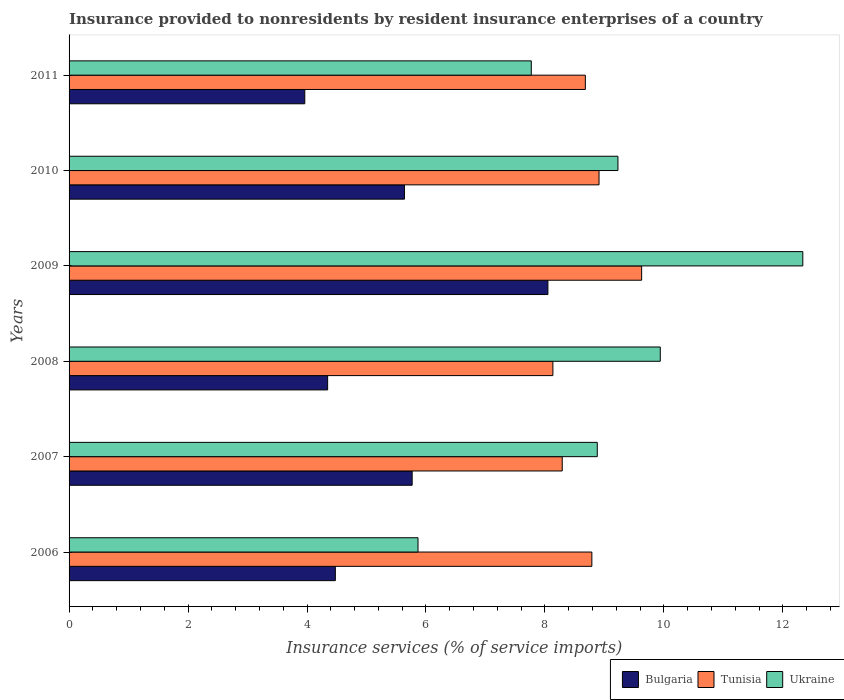How many different coloured bars are there?
Keep it short and to the point. 3. How many groups of bars are there?
Offer a very short reply. 6. Are the number of bars on each tick of the Y-axis equal?
Keep it short and to the point. Yes. What is the insurance provided to nonresidents in Tunisia in 2006?
Provide a succinct answer. 8.79. Across all years, what is the maximum insurance provided to nonresidents in Tunisia?
Ensure brevity in your answer.  9.63. Across all years, what is the minimum insurance provided to nonresidents in Ukraine?
Offer a terse response. 5.87. In which year was the insurance provided to nonresidents in Bulgaria minimum?
Ensure brevity in your answer.  2011. What is the total insurance provided to nonresidents in Bulgaria in the graph?
Keep it short and to the point. 32.24. What is the difference between the insurance provided to nonresidents in Bulgaria in 2006 and that in 2008?
Offer a terse response. 0.13. What is the difference between the insurance provided to nonresidents in Bulgaria in 2010 and the insurance provided to nonresidents in Ukraine in 2008?
Ensure brevity in your answer.  -4.3. What is the average insurance provided to nonresidents in Bulgaria per year?
Give a very brief answer. 5.37. In the year 2010, what is the difference between the insurance provided to nonresidents in Ukraine and insurance provided to nonresidents in Bulgaria?
Keep it short and to the point. 3.59. In how many years, is the insurance provided to nonresidents in Ukraine greater than 7.6 %?
Offer a very short reply. 5. What is the ratio of the insurance provided to nonresidents in Ukraine in 2007 to that in 2011?
Keep it short and to the point. 1.14. Is the insurance provided to nonresidents in Ukraine in 2007 less than that in 2010?
Your answer should be very brief. Yes. Is the difference between the insurance provided to nonresidents in Ukraine in 2007 and 2010 greater than the difference between the insurance provided to nonresidents in Bulgaria in 2007 and 2010?
Your response must be concise. No. What is the difference between the highest and the second highest insurance provided to nonresidents in Ukraine?
Your answer should be compact. 2.4. What is the difference between the highest and the lowest insurance provided to nonresidents in Tunisia?
Provide a short and direct response. 1.49. In how many years, is the insurance provided to nonresidents in Tunisia greater than the average insurance provided to nonresidents in Tunisia taken over all years?
Your response must be concise. 3. What does the 2nd bar from the top in 2011 represents?
Offer a terse response. Tunisia. Is it the case that in every year, the sum of the insurance provided to nonresidents in Tunisia and insurance provided to nonresidents in Ukraine is greater than the insurance provided to nonresidents in Bulgaria?
Your answer should be compact. Yes. How many bars are there?
Ensure brevity in your answer.  18. What is the difference between two consecutive major ticks on the X-axis?
Provide a succinct answer. 2. Where does the legend appear in the graph?
Make the answer very short. Bottom right. How many legend labels are there?
Give a very brief answer. 3. How are the legend labels stacked?
Your answer should be very brief. Horizontal. What is the title of the graph?
Your response must be concise. Insurance provided to nonresidents by resident insurance enterprises of a country. What is the label or title of the X-axis?
Offer a very short reply. Insurance services (% of service imports). What is the Insurance services (% of service imports) in Bulgaria in 2006?
Your answer should be very brief. 4.48. What is the Insurance services (% of service imports) of Tunisia in 2006?
Give a very brief answer. 8.79. What is the Insurance services (% of service imports) of Ukraine in 2006?
Ensure brevity in your answer.  5.87. What is the Insurance services (% of service imports) of Bulgaria in 2007?
Give a very brief answer. 5.77. What is the Insurance services (% of service imports) in Tunisia in 2007?
Ensure brevity in your answer.  8.29. What is the Insurance services (% of service imports) of Ukraine in 2007?
Your response must be concise. 8.88. What is the Insurance services (% of service imports) in Bulgaria in 2008?
Make the answer very short. 4.35. What is the Insurance services (% of service imports) in Tunisia in 2008?
Your answer should be very brief. 8.13. What is the Insurance services (% of service imports) of Ukraine in 2008?
Your answer should be compact. 9.94. What is the Insurance services (% of service imports) of Bulgaria in 2009?
Offer a very short reply. 8.05. What is the Insurance services (% of service imports) in Tunisia in 2009?
Make the answer very short. 9.63. What is the Insurance services (% of service imports) in Ukraine in 2009?
Keep it short and to the point. 12.34. What is the Insurance services (% of service imports) of Bulgaria in 2010?
Offer a terse response. 5.64. What is the Insurance services (% of service imports) in Tunisia in 2010?
Provide a short and direct response. 8.91. What is the Insurance services (% of service imports) of Ukraine in 2010?
Provide a short and direct response. 9.23. What is the Insurance services (% of service imports) in Bulgaria in 2011?
Ensure brevity in your answer.  3.96. What is the Insurance services (% of service imports) of Tunisia in 2011?
Your answer should be compact. 8.68. What is the Insurance services (% of service imports) in Ukraine in 2011?
Your answer should be very brief. 7.77. Across all years, what is the maximum Insurance services (% of service imports) in Bulgaria?
Ensure brevity in your answer.  8.05. Across all years, what is the maximum Insurance services (% of service imports) in Tunisia?
Your answer should be very brief. 9.63. Across all years, what is the maximum Insurance services (% of service imports) in Ukraine?
Ensure brevity in your answer.  12.34. Across all years, what is the minimum Insurance services (% of service imports) in Bulgaria?
Offer a terse response. 3.96. Across all years, what is the minimum Insurance services (% of service imports) of Tunisia?
Ensure brevity in your answer.  8.13. Across all years, what is the minimum Insurance services (% of service imports) of Ukraine?
Provide a succinct answer. 5.87. What is the total Insurance services (% of service imports) of Bulgaria in the graph?
Ensure brevity in your answer.  32.24. What is the total Insurance services (% of service imports) in Tunisia in the graph?
Your response must be concise. 52.43. What is the total Insurance services (% of service imports) in Ukraine in the graph?
Your answer should be compact. 54.02. What is the difference between the Insurance services (% of service imports) in Bulgaria in 2006 and that in 2007?
Your response must be concise. -1.29. What is the difference between the Insurance services (% of service imports) of Tunisia in 2006 and that in 2007?
Offer a terse response. 0.5. What is the difference between the Insurance services (% of service imports) of Ukraine in 2006 and that in 2007?
Provide a succinct answer. -3.01. What is the difference between the Insurance services (% of service imports) of Bulgaria in 2006 and that in 2008?
Offer a very short reply. 0.13. What is the difference between the Insurance services (% of service imports) of Tunisia in 2006 and that in 2008?
Provide a succinct answer. 0.66. What is the difference between the Insurance services (% of service imports) of Ukraine in 2006 and that in 2008?
Make the answer very short. -4.07. What is the difference between the Insurance services (% of service imports) of Bulgaria in 2006 and that in 2009?
Your answer should be very brief. -3.57. What is the difference between the Insurance services (% of service imports) in Tunisia in 2006 and that in 2009?
Provide a succinct answer. -0.84. What is the difference between the Insurance services (% of service imports) in Ukraine in 2006 and that in 2009?
Ensure brevity in your answer.  -6.47. What is the difference between the Insurance services (% of service imports) in Bulgaria in 2006 and that in 2010?
Ensure brevity in your answer.  -1.16. What is the difference between the Insurance services (% of service imports) in Tunisia in 2006 and that in 2010?
Provide a short and direct response. -0.12. What is the difference between the Insurance services (% of service imports) of Ukraine in 2006 and that in 2010?
Your answer should be very brief. -3.36. What is the difference between the Insurance services (% of service imports) in Bulgaria in 2006 and that in 2011?
Offer a terse response. 0.51. What is the difference between the Insurance services (% of service imports) in Tunisia in 2006 and that in 2011?
Offer a terse response. 0.11. What is the difference between the Insurance services (% of service imports) of Ukraine in 2006 and that in 2011?
Give a very brief answer. -1.9. What is the difference between the Insurance services (% of service imports) in Bulgaria in 2007 and that in 2008?
Your answer should be very brief. 1.42. What is the difference between the Insurance services (% of service imports) of Tunisia in 2007 and that in 2008?
Your answer should be very brief. 0.16. What is the difference between the Insurance services (% of service imports) of Ukraine in 2007 and that in 2008?
Give a very brief answer. -1.06. What is the difference between the Insurance services (% of service imports) in Bulgaria in 2007 and that in 2009?
Provide a short and direct response. -2.28. What is the difference between the Insurance services (% of service imports) of Tunisia in 2007 and that in 2009?
Your answer should be compact. -1.33. What is the difference between the Insurance services (% of service imports) in Ukraine in 2007 and that in 2009?
Provide a short and direct response. -3.46. What is the difference between the Insurance services (% of service imports) in Bulgaria in 2007 and that in 2010?
Your answer should be compact. 0.13. What is the difference between the Insurance services (% of service imports) in Tunisia in 2007 and that in 2010?
Make the answer very short. -0.62. What is the difference between the Insurance services (% of service imports) in Ukraine in 2007 and that in 2010?
Offer a terse response. -0.35. What is the difference between the Insurance services (% of service imports) of Bulgaria in 2007 and that in 2011?
Your response must be concise. 1.81. What is the difference between the Insurance services (% of service imports) in Tunisia in 2007 and that in 2011?
Keep it short and to the point. -0.39. What is the difference between the Insurance services (% of service imports) of Ukraine in 2007 and that in 2011?
Provide a succinct answer. 1.11. What is the difference between the Insurance services (% of service imports) of Bulgaria in 2008 and that in 2009?
Your answer should be very brief. -3.7. What is the difference between the Insurance services (% of service imports) of Tunisia in 2008 and that in 2009?
Offer a very short reply. -1.49. What is the difference between the Insurance services (% of service imports) of Ukraine in 2008 and that in 2009?
Make the answer very short. -2.4. What is the difference between the Insurance services (% of service imports) of Bulgaria in 2008 and that in 2010?
Provide a succinct answer. -1.29. What is the difference between the Insurance services (% of service imports) in Tunisia in 2008 and that in 2010?
Make the answer very short. -0.78. What is the difference between the Insurance services (% of service imports) in Ukraine in 2008 and that in 2010?
Provide a succinct answer. 0.71. What is the difference between the Insurance services (% of service imports) in Bulgaria in 2008 and that in 2011?
Provide a short and direct response. 0.38. What is the difference between the Insurance services (% of service imports) of Tunisia in 2008 and that in 2011?
Your answer should be compact. -0.55. What is the difference between the Insurance services (% of service imports) of Ukraine in 2008 and that in 2011?
Provide a short and direct response. 2.17. What is the difference between the Insurance services (% of service imports) of Bulgaria in 2009 and that in 2010?
Ensure brevity in your answer.  2.41. What is the difference between the Insurance services (% of service imports) in Tunisia in 2009 and that in 2010?
Your answer should be very brief. 0.72. What is the difference between the Insurance services (% of service imports) in Ukraine in 2009 and that in 2010?
Give a very brief answer. 3.11. What is the difference between the Insurance services (% of service imports) of Bulgaria in 2009 and that in 2011?
Offer a terse response. 4.09. What is the difference between the Insurance services (% of service imports) of Tunisia in 2009 and that in 2011?
Offer a terse response. 0.95. What is the difference between the Insurance services (% of service imports) of Ukraine in 2009 and that in 2011?
Provide a succinct answer. 4.56. What is the difference between the Insurance services (% of service imports) in Bulgaria in 2010 and that in 2011?
Your answer should be compact. 1.68. What is the difference between the Insurance services (% of service imports) of Tunisia in 2010 and that in 2011?
Make the answer very short. 0.23. What is the difference between the Insurance services (% of service imports) of Ukraine in 2010 and that in 2011?
Provide a succinct answer. 1.46. What is the difference between the Insurance services (% of service imports) of Bulgaria in 2006 and the Insurance services (% of service imports) of Tunisia in 2007?
Ensure brevity in your answer.  -3.81. What is the difference between the Insurance services (% of service imports) of Bulgaria in 2006 and the Insurance services (% of service imports) of Ukraine in 2007?
Your response must be concise. -4.4. What is the difference between the Insurance services (% of service imports) of Tunisia in 2006 and the Insurance services (% of service imports) of Ukraine in 2007?
Make the answer very short. -0.09. What is the difference between the Insurance services (% of service imports) in Bulgaria in 2006 and the Insurance services (% of service imports) in Tunisia in 2008?
Ensure brevity in your answer.  -3.66. What is the difference between the Insurance services (% of service imports) in Bulgaria in 2006 and the Insurance services (% of service imports) in Ukraine in 2008?
Keep it short and to the point. -5.46. What is the difference between the Insurance services (% of service imports) in Tunisia in 2006 and the Insurance services (% of service imports) in Ukraine in 2008?
Offer a very short reply. -1.15. What is the difference between the Insurance services (% of service imports) of Bulgaria in 2006 and the Insurance services (% of service imports) of Tunisia in 2009?
Your response must be concise. -5.15. What is the difference between the Insurance services (% of service imports) of Bulgaria in 2006 and the Insurance services (% of service imports) of Ukraine in 2009?
Ensure brevity in your answer.  -7.86. What is the difference between the Insurance services (% of service imports) in Tunisia in 2006 and the Insurance services (% of service imports) in Ukraine in 2009?
Ensure brevity in your answer.  -3.55. What is the difference between the Insurance services (% of service imports) in Bulgaria in 2006 and the Insurance services (% of service imports) in Tunisia in 2010?
Give a very brief answer. -4.43. What is the difference between the Insurance services (% of service imports) of Bulgaria in 2006 and the Insurance services (% of service imports) of Ukraine in 2010?
Ensure brevity in your answer.  -4.75. What is the difference between the Insurance services (% of service imports) of Tunisia in 2006 and the Insurance services (% of service imports) of Ukraine in 2010?
Provide a succinct answer. -0.44. What is the difference between the Insurance services (% of service imports) of Bulgaria in 2006 and the Insurance services (% of service imports) of Tunisia in 2011?
Keep it short and to the point. -4.2. What is the difference between the Insurance services (% of service imports) of Bulgaria in 2006 and the Insurance services (% of service imports) of Ukraine in 2011?
Make the answer very short. -3.29. What is the difference between the Insurance services (% of service imports) of Tunisia in 2006 and the Insurance services (% of service imports) of Ukraine in 2011?
Give a very brief answer. 1.02. What is the difference between the Insurance services (% of service imports) in Bulgaria in 2007 and the Insurance services (% of service imports) in Tunisia in 2008?
Make the answer very short. -2.37. What is the difference between the Insurance services (% of service imports) in Bulgaria in 2007 and the Insurance services (% of service imports) in Ukraine in 2008?
Ensure brevity in your answer.  -4.17. What is the difference between the Insurance services (% of service imports) of Tunisia in 2007 and the Insurance services (% of service imports) of Ukraine in 2008?
Offer a very short reply. -1.65. What is the difference between the Insurance services (% of service imports) of Bulgaria in 2007 and the Insurance services (% of service imports) of Tunisia in 2009?
Give a very brief answer. -3.86. What is the difference between the Insurance services (% of service imports) of Bulgaria in 2007 and the Insurance services (% of service imports) of Ukraine in 2009?
Your answer should be compact. -6.57. What is the difference between the Insurance services (% of service imports) of Tunisia in 2007 and the Insurance services (% of service imports) of Ukraine in 2009?
Offer a terse response. -4.04. What is the difference between the Insurance services (% of service imports) in Bulgaria in 2007 and the Insurance services (% of service imports) in Tunisia in 2010?
Provide a short and direct response. -3.14. What is the difference between the Insurance services (% of service imports) in Bulgaria in 2007 and the Insurance services (% of service imports) in Ukraine in 2010?
Provide a short and direct response. -3.46. What is the difference between the Insurance services (% of service imports) in Tunisia in 2007 and the Insurance services (% of service imports) in Ukraine in 2010?
Keep it short and to the point. -0.94. What is the difference between the Insurance services (% of service imports) of Bulgaria in 2007 and the Insurance services (% of service imports) of Tunisia in 2011?
Offer a terse response. -2.91. What is the difference between the Insurance services (% of service imports) of Bulgaria in 2007 and the Insurance services (% of service imports) of Ukraine in 2011?
Your answer should be compact. -2. What is the difference between the Insurance services (% of service imports) of Tunisia in 2007 and the Insurance services (% of service imports) of Ukraine in 2011?
Ensure brevity in your answer.  0.52. What is the difference between the Insurance services (% of service imports) in Bulgaria in 2008 and the Insurance services (% of service imports) in Tunisia in 2009?
Your answer should be very brief. -5.28. What is the difference between the Insurance services (% of service imports) in Bulgaria in 2008 and the Insurance services (% of service imports) in Ukraine in 2009?
Your answer should be compact. -7.99. What is the difference between the Insurance services (% of service imports) in Tunisia in 2008 and the Insurance services (% of service imports) in Ukraine in 2009?
Offer a terse response. -4.2. What is the difference between the Insurance services (% of service imports) in Bulgaria in 2008 and the Insurance services (% of service imports) in Tunisia in 2010?
Ensure brevity in your answer.  -4.56. What is the difference between the Insurance services (% of service imports) of Bulgaria in 2008 and the Insurance services (% of service imports) of Ukraine in 2010?
Your answer should be compact. -4.88. What is the difference between the Insurance services (% of service imports) of Tunisia in 2008 and the Insurance services (% of service imports) of Ukraine in 2010?
Your answer should be very brief. -1.09. What is the difference between the Insurance services (% of service imports) of Bulgaria in 2008 and the Insurance services (% of service imports) of Tunisia in 2011?
Offer a terse response. -4.33. What is the difference between the Insurance services (% of service imports) in Bulgaria in 2008 and the Insurance services (% of service imports) in Ukraine in 2011?
Offer a terse response. -3.42. What is the difference between the Insurance services (% of service imports) of Tunisia in 2008 and the Insurance services (% of service imports) of Ukraine in 2011?
Keep it short and to the point. 0.36. What is the difference between the Insurance services (% of service imports) in Bulgaria in 2009 and the Insurance services (% of service imports) in Tunisia in 2010?
Your answer should be very brief. -0.86. What is the difference between the Insurance services (% of service imports) in Bulgaria in 2009 and the Insurance services (% of service imports) in Ukraine in 2010?
Provide a succinct answer. -1.18. What is the difference between the Insurance services (% of service imports) of Tunisia in 2009 and the Insurance services (% of service imports) of Ukraine in 2010?
Offer a very short reply. 0.4. What is the difference between the Insurance services (% of service imports) of Bulgaria in 2009 and the Insurance services (% of service imports) of Tunisia in 2011?
Give a very brief answer. -0.63. What is the difference between the Insurance services (% of service imports) in Bulgaria in 2009 and the Insurance services (% of service imports) in Ukraine in 2011?
Ensure brevity in your answer.  0.28. What is the difference between the Insurance services (% of service imports) of Tunisia in 2009 and the Insurance services (% of service imports) of Ukraine in 2011?
Keep it short and to the point. 1.85. What is the difference between the Insurance services (% of service imports) in Bulgaria in 2010 and the Insurance services (% of service imports) in Tunisia in 2011?
Provide a short and direct response. -3.04. What is the difference between the Insurance services (% of service imports) of Bulgaria in 2010 and the Insurance services (% of service imports) of Ukraine in 2011?
Your response must be concise. -2.13. What is the difference between the Insurance services (% of service imports) in Tunisia in 2010 and the Insurance services (% of service imports) in Ukraine in 2011?
Provide a succinct answer. 1.14. What is the average Insurance services (% of service imports) in Bulgaria per year?
Provide a succinct answer. 5.37. What is the average Insurance services (% of service imports) in Tunisia per year?
Offer a very short reply. 8.74. What is the average Insurance services (% of service imports) in Ukraine per year?
Ensure brevity in your answer.  9. In the year 2006, what is the difference between the Insurance services (% of service imports) of Bulgaria and Insurance services (% of service imports) of Tunisia?
Provide a short and direct response. -4.31. In the year 2006, what is the difference between the Insurance services (% of service imports) of Bulgaria and Insurance services (% of service imports) of Ukraine?
Keep it short and to the point. -1.39. In the year 2006, what is the difference between the Insurance services (% of service imports) of Tunisia and Insurance services (% of service imports) of Ukraine?
Offer a terse response. 2.92. In the year 2007, what is the difference between the Insurance services (% of service imports) of Bulgaria and Insurance services (% of service imports) of Tunisia?
Offer a terse response. -2.52. In the year 2007, what is the difference between the Insurance services (% of service imports) in Bulgaria and Insurance services (% of service imports) in Ukraine?
Your answer should be very brief. -3.11. In the year 2007, what is the difference between the Insurance services (% of service imports) of Tunisia and Insurance services (% of service imports) of Ukraine?
Offer a very short reply. -0.59. In the year 2008, what is the difference between the Insurance services (% of service imports) of Bulgaria and Insurance services (% of service imports) of Tunisia?
Offer a very short reply. -3.79. In the year 2008, what is the difference between the Insurance services (% of service imports) of Bulgaria and Insurance services (% of service imports) of Ukraine?
Your answer should be very brief. -5.59. In the year 2008, what is the difference between the Insurance services (% of service imports) in Tunisia and Insurance services (% of service imports) in Ukraine?
Offer a very short reply. -1.81. In the year 2009, what is the difference between the Insurance services (% of service imports) of Bulgaria and Insurance services (% of service imports) of Tunisia?
Your response must be concise. -1.58. In the year 2009, what is the difference between the Insurance services (% of service imports) of Bulgaria and Insurance services (% of service imports) of Ukraine?
Your answer should be very brief. -4.29. In the year 2009, what is the difference between the Insurance services (% of service imports) of Tunisia and Insurance services (% of service imports) of Ukraine?
Your response must be concise. -2.71. In the year 2010, what is the difference between the Insurance services (% of service imports) of Bulgaria and Insurance services (% of service imports) of Tunisia?
Provide a short and direct response. -3.27. In the year 2010, what is the difference between the Insurance services (% of service imports) in Bulgaria and Insurance services (% of service imports) in Ukraine?
Give a very brief answer. -3.59. In the year 2010, what is the difference between the Insurance services (% of service imports) of Tunisia and Insurance services (% of service imports) of Ukraine?
Offer a terse response. -0.32. In the year 2011, what is the difference between the Insurance services (% of service imports) in Bulgaria and Insurance services (% of service imports) in Tunisia?
Your response must be concise. -4.72. In the year 2011, what is the difference between the Insurance services (% of service imports) of Bulgaria and Insurance services (% of service imports) of Ukraine?
Your answer should be very brief. -3.81. In the year 2011, what is the difference between the Insurance services (% of service imports) in Tunisia and Insurance services (% of service imports) in Ukraine?
Provide a succinct answer. 0.91. What is the ratio of the Insurance services (% of service imports) in Bulgaria in 2006 to that in 2007?
Offer a terse response. 0.78. What is the ratio of the Insurance services (% of service imports) in Tunisia in 2006 to that in 2007?
Your response must be concise. 1.06. What is the ratio of the Insurance services (% of service imports) of Ukraine in 2006 to that in 2007?
Make the answer very short. 0.66. What is the ratio of the Insurance services (% of service imports) in Bulgaria in 2006 to that in 2008?
Make the answer very short. 1.03. What is the ratio of the Insurance services (% of service imports) in Tunisia in 2006 to that in 2008?
Provide a succinct answer. 1.08. What is the ratio of the Insurance services (% of service imports) in Ukraine in 2006 to that in 2008?
Give a very brief answer. 0.59. What is the ratio of the Insurance services (% of service imports) of Bulgaria in 2006 to that in 2009?
Keep it short and to the point. 0.56. What is the ratio of the Insurance services (% of service imports) of Tunisia in 2006 to that in 2009?
Provide a short and direct response. 0.91. What is the ratio of the Insurance services (% of service imports) of Ukraine in 2006 to that in 2009?
Your answer should be very brief. 0.48. What is the ratio of the Insurance services (% of service imports) in Bulgaria in 2006 to that in 2010?
Give a very brief answer. 0.79. What is the ratio of the Insurance services (% of service imports) in Tunisia in 2006 to that in 2010?
Your answer should be very brief. 0.99. What is the ratio of the Insurance services (% of service imports) of Ukraine in 2006 to that in 2010?
Provide a succinct answer. 0.64. What is the ratio of the Insurance services (% of service imports) in Bulgaria in 2006 to that in 2011?
Ensure brevity in your answer.  1.13. What is the ratio of the Insurance services (% of service imports) in Tunisia in 2006 to that in 2011?
Provide a succinct answer. 1.01. What is the ratio of the Insurance services (% of service imports) of Ukraine in 2006 to that in 2011?
Your answer should be very brief. 0.75. What is the ratio of the Insurance services (% of service imports) of Bulgaria in 2007 to that in 2008?
Your response must be concise. 1.33. What is the ratio of the Insurance services (% of service imports) in Tunisia in 2007 to that in 2008?
Your response must be concise. 1.02. What is the ratio of the Insurance services (% of service imports) in Ukraine in 2007 to that in 2008?
Give a very brief answer. 0.89. What is the ratio of the Insurance services (% of service imports) of Bulgaria in 2007 to that in 2009?
Give a very brief answer. 0.72. What is the ratio of the Insurance services (% of service imports) in Tunisia in 2007 to that in 2009?
Your answer should be compact. 0.86. What is the ratio of the Insurance services (% of service imports) in Ukraine in 2007 to that in 2009?
Ensure brevity in your answer.  0.72. What is the ratio of the Insurance services (% of service imports) in Bulgaria in 2007 to that in 2010?
Offer a terse response. 1.02. What is the ratio of the Insurance services (% of service imports) in Tunisia in 2007 to that in 2010?
Offer a terse response. 0.93. What is the ratio of the Insurance services (% of service imports) in Ukraine in 2007 to that in 2010?
Keep it short and to the point. 0.96. What is the ratio of the Insurance services (% of service imports) in Bulgaria in 2007 to that in 2011?
Offer a terse response. 1.46. What is the ratio of the Insurance services (% of service imports) in Tunisia in 2007 to that in 2011?
Offer a very short reply. 0.96. What is the ratio of the Insurance services (% of service imports) in Ukraine in 2007 to that in 2011?
Keep it short and to the point. 1.14. What is the ratio of the Insurance services (% of service imports) in Bulgaria in 2008 to that in 2009?
Give a very brief answer. 0.54. What is the ratio of the Insurance services (% of service imports) in Tunisia in 2008 to that in 2009?
Your response must be concise. 0.84. What is the ratio of the Insurance services (% of service imports) in Ukraine in 2008 to that in 2009?
Give a very brief answer. 0.81. What is the ratio of the Insurance services (% of service imports) in Bulgaria in 2008 to that in 2010?
Keep it short and to the point. 0.77. What is the ratio of the Insurance services (% of service imports) of Tunisia in 2008 to that in 2010?
Keep it short and to the point. 0.91. What is the ratio of the Insurance services (% of service imports) of Ukraine in 2008 to that in 2010?
Give a very brief answer. 1.08. What is the ratio of the Insurance services (% of service imports) in Bulgaria in 2008 to that in 2011?
Your response must be concise. 1.1. What is the ratio of the Insurance services (% of service imports) in Tunisia in 2008 to that in 2011?
Make the answer very short. 0.94. What is the ratio of the Insurance services (% of service imports) in Ukraine in 2008 to that in 2011?
Your answer should be compact. 1.28. What is the ratio of the Insurance services (% of service imports) in Bulgaria in 2009 to that in 2010?
Your answer should be compact. 1.43. What is the ratio of the Insurance services (% of service imports) in Tunisia in 2009 to that in 2010?
Give a very brief answer. 1.08. What is the ratio of the Insurance services (% of service imports) of Ukraine in 2009 to that in 2010?
Offer a terse response. 1.34. What is the ratio of the Insurance services (% of service imports) of Bulgaria in 2009 to that in 2011?
Offer a terse response. 2.03. What is the ratio of the Insurance services (% of service imports) in Tunisia in 2009 to that in 2011?
Provide a short and direct response. 1.11. What is the ratio of the Insurance services (% of service imports) of Ukraine in 2009 to that in 2011?
Provide a short and direct response. 1.59. What is the ratio of the Insurance services (% of service imports) in Bulgaria in 2010 to that in 2011?
Ensure brevity in your answer.  1.42. What is the ratio of the Insurance services (% of service imports) of Tunisia in 2010 to that in 2011?
Your answer should be very brief. 1.03. What is the ratio of the Insurance services (% of service imports) in Ukraine in 2010 to that in 2011?
Provide a succinct answer. 1.19. What is the difference between the highest and the second highest Insurance services (% of service imports) in Bulgaria?
Give a very brief answer. 2.28. What is the difference between the highest and the second highest Insurance services (% of service imports) in Tunisia?
Your answer should be compact. 0.72. What is the difference between the highest and the second highest Insurance services (% of service imports) in Ukraine?
Your answer should be very brief. 2.4. What is the difference between the highest and the lowest Insurance services (% of service imports) of Bulgaria?
Your answer should be very brief. 4.09. What is the difference between the highest and the lowest Insurance services (% of service imports) in Tunisia?
Your response must be concise. 1.49. What is the difference between the highest and the lowest Insurance services (% of service imports) in Ukraine?
Provide a short and direct response. 6.47. 